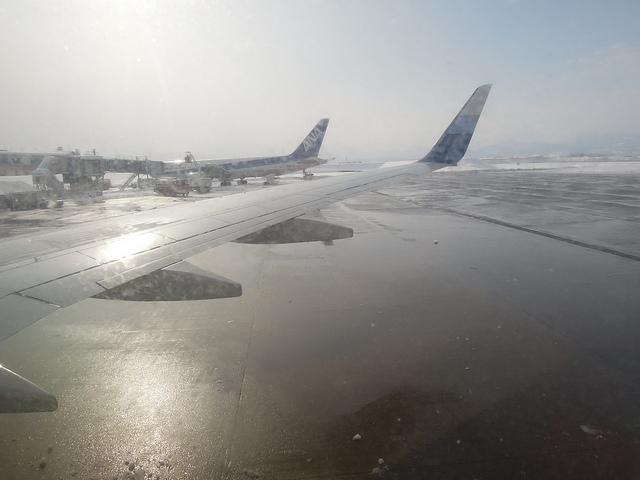Is it night or day?
Concise answer only. Day. Is there more than one airplane?
Answer briefly. Yes. Can you see an ocean?
Quick response, please. Yes. 